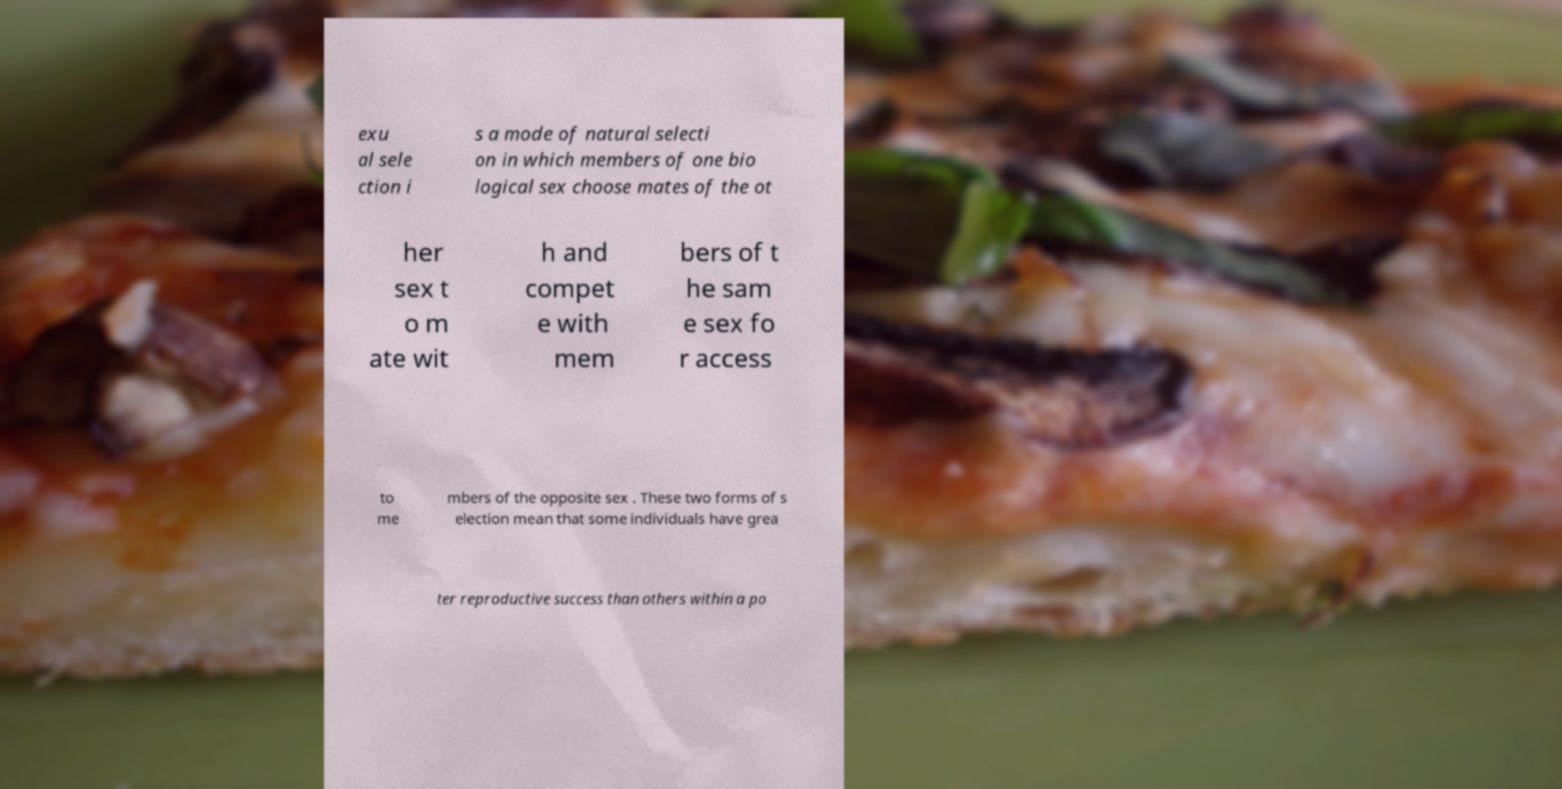What messages or text are displayed in this image? I need them in a readable, typed format. exu al sele ction i s a mode of natural selecti on in which members of one bio logical sex choose mates of the ot her sex t o m ate wit h and compet e with mem bers of t he sam e sex fo r access to me mbers of the opposite sex . These two forms of s election mean that some individuals have grea ter reproductive success than others within a po 